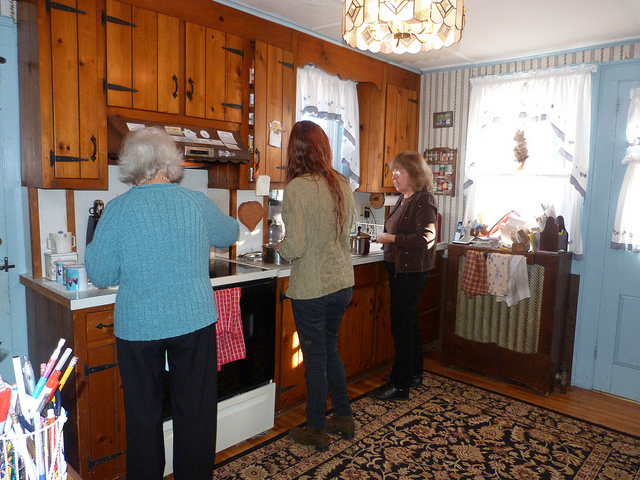How many people are in the photo? 3 